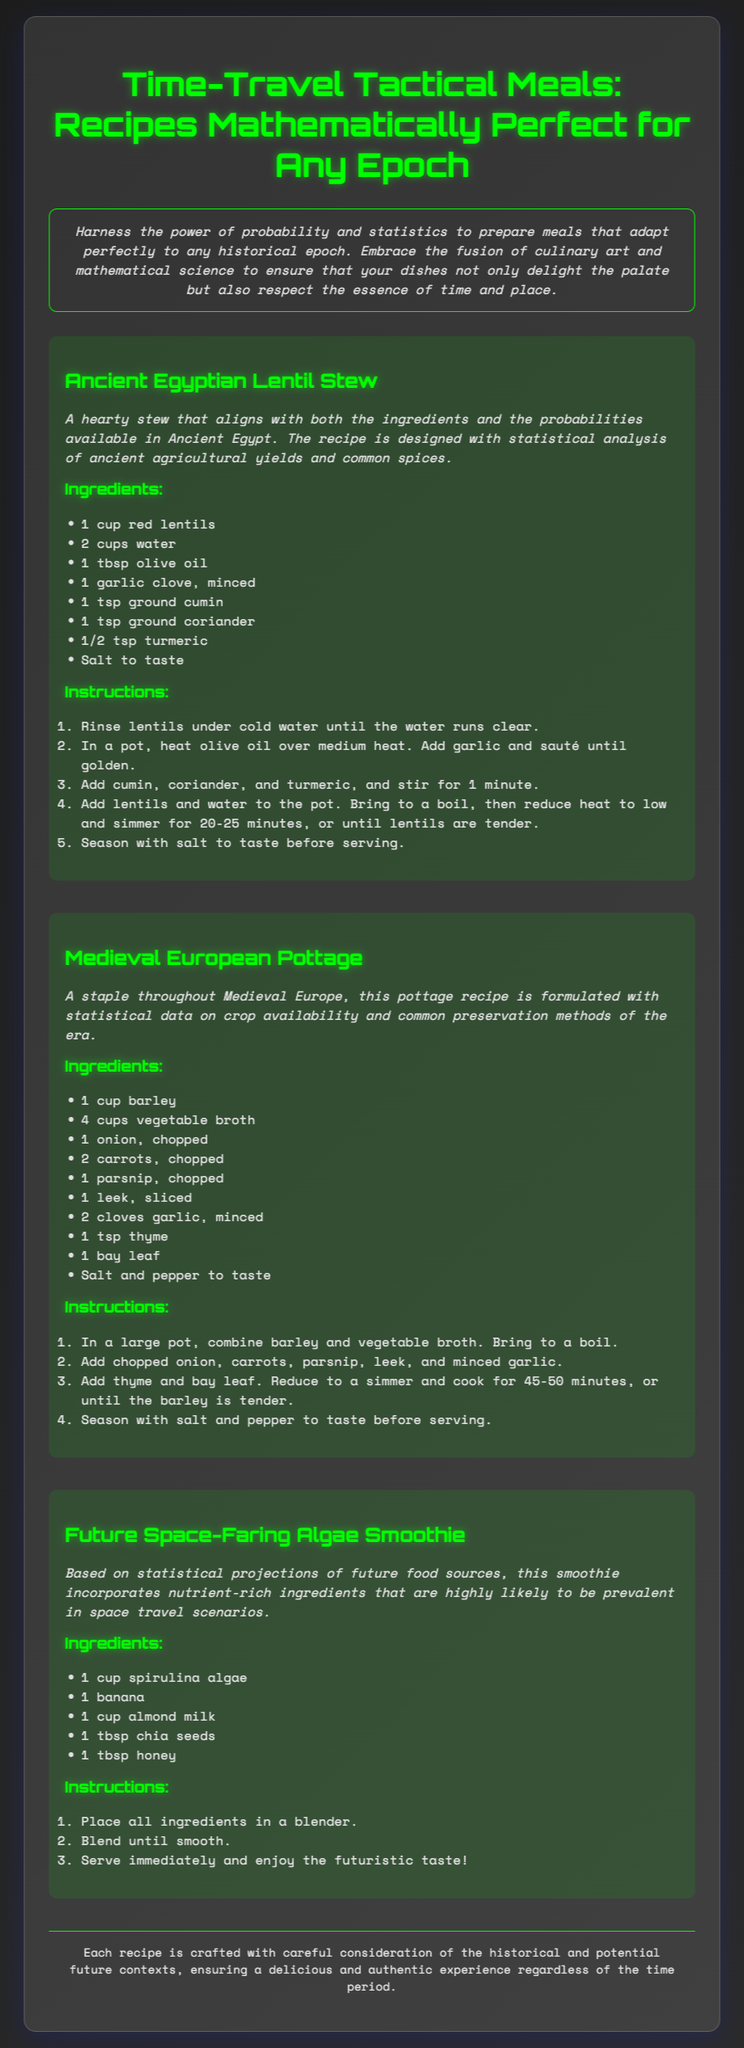what is the title of the document? The title of the document is prominently displayed at the top of the page in larger font.
Answer: Time-Travel Tactical Meals: Recipes Mathematically Perfect for Any Epoch how many recipes are included in the document? The document lists three distinct recipes within its content.
Answer: 3 what is the main ingredient in the Ancient Egyptian Lentil Stew? The main ingredient is listed first in the ingredients section for this recipe.
Answer: red lentils how long should the Medieval European Pottage simmer? The cooking time is specified in the instructions for the pottage recipe.
Answer: 45-50 minutes which ingredient indicates a futuristic context in the recipes? The ingredient list includes a specific item that is associated with future food sources in space travel.
Answer: spirulina algae what type of cuisine is represented in the second recipe? The title of the recipe signifies the geographical and historical influence of the dish.
Answer: Medieval European what is the method of cooking described for the Ancient Egyptian Lentil Stew? The instructions detail the steps involved in preparing this stew.
Answer: simmer what herb is used in the Medieval European Pottage? The ingredients section lists a specific herb associated with flavoring this dish.
Answer: thyme 